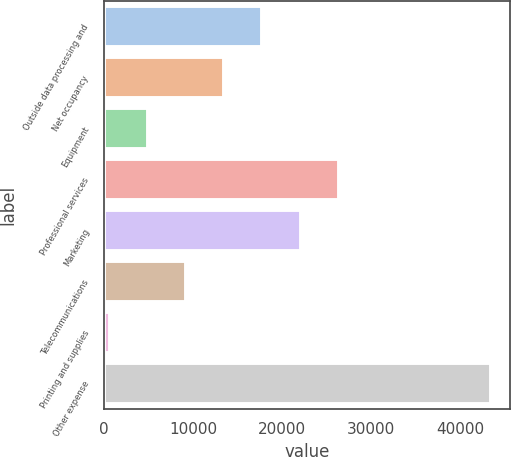Convert chart. <chart><loc_0><loc_0><loc_500><loc_500><bar_chart><fcel>Outside data processing and<fcel>Net occupancy<fcel>Equipment<fcel>Professional services<fcel>Marketing<fcel>Telecommunications<fcel>Printing and supplies<fcel>Other expense<nl><fcel>17788<fcel>13515<fcel>4969<fcel>26334<fcel>22061<fcel>9242<fcel>696<fcel>43426<nl></chart> 